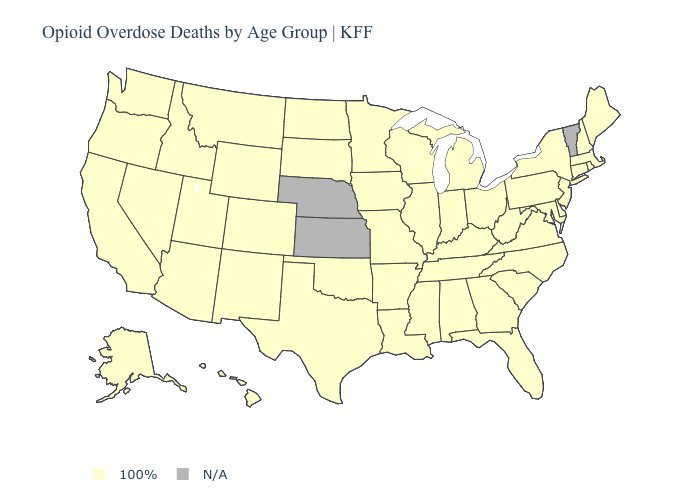Name the states that have a value in the range 100%?
Answer briefly. Alabama, Alaska, Arizona, Arkansas, California, Colorado, Connecticut, Delaware, Florida, Georgia, Hawaii, Idaho, Illinois, Indiana, Iowa, Kentucky, Louisiana, Maine, Maryland, Massachusetts, Michigan, Minnesota, Mississippi, Missouri, Montana, Nevada, New Hampshire, New Jersey, New Mexico, New York, North Carolina, North Dakota, Ohio, Oklahoma, Oregon, Pennsylvania, Rhode Island, South Carolina, South Dakota, Tennessee, Texas, Utah, Virginia, Washington, West Virginia, Wisconsin, Wyoming. Name the states that have a value in the range 100%?
Keep it brief. Alabama, Alaska, Arizona, Arkansas, California, Colorado, Connecticut, Delaware, Florida, Georgia, Hawaii, Idaho, Illinois, Indiana, Iowa, Kentucky, Louisiana, Maine, Maryland, Massachusetts, Michigan, Minnesota, Mississippi, Missouri, Montana, Nevada, New Hampshire, New Jersey, New Mexico, New York, North Carolina, North Dakota, Ohio, Oklahoma, Oregon, Pennsylvania, Rhode Island, South Carolina, South Dakota, Tennessee, Texas, Utah, Virginia, Washington, West Virginia, Wisconsin, Wyoming. Name the states that have a value in the range 100%?
Short answer required. Alabama, Alaska, Arizona, Arkansas, California, Colorado, Connecticut, Delaware, Florida, Georgia, Hawaii, Idaho, Illinois, Indiana, Iowa, Kentucky, Louisiana, Maine, Maryland, Massachusetts, Michigan, Minnesota, Mississippi, Missouri, Montana, Nevada, New Hampshire, New Jersey, New Mexico, New York, North Carolina, North Dakota, Ohio, Oklahoma, Oregon, Pennsylvania, Rhode Island, South Carolina, South Dakota, Tennessee, Texas, Utah, Virginia, Washington, West Virginia, Wisconsin, Wyoming. What is the value of New Hampshire?
Short answer required. 100%. Which states have the highest value in the USA?
Keep it brief. Alabama, Alaska, Arizona, Arkansas, California, Colorado, Connecticut, Delaware, Florida, Georgia, Hawaii, Idaho, Illinois, Indiana, Iowa, Kentucky, Louisiana, Maine, Maryland, Massachusetts, Michigan, Minnesota, Mississippi, Missouri, Montana, Nevada, New Hampshire, New Jersey, New Mexico, New York, North Carolina, North Dakota, Ohio, Oklahoma, Oregon, Pennsylvania, Rhode Island, South Carolina, South Dakota, Tennessee, Texas, Utah, Virginia, Washington, West Virginia, Wisconsin, Wyoming. Which states have the highest value in the USA?
Write a very short answer. Alabama, Alaska, Arizona, Arkansas, California, Colorado, Connecticut, Delaware, Florida, Georgia, Hawaii, Idaho, Illinois, Indiana, Iowa, Kentucky, Louisiana, Maine, Maryland, Massachusetts, Michigan, Minnesota, Mississippi, Missouri, Montana, Nevada, New Hampshire, New Jersey, New Mexico, New York, North Carolina, North Dakota, Ohio, Oklahoma, Oregon, Pennsylvania, Rhode Island, South Carolina, South Dakota, Tennessee, Texas, Utah, Virginia, Washington, West Virginia, Wisconsin, Wyoming. Which states have the lowest value in the USA?
Concise answer only. Alabama, Alaska, Arizona, Arkansas, California, Colorado, Connecticut, Delaware, Florida, Georgia, Hawaii, Idaho, Illinois, Indiana, Iowa, Kentucky, Louisiana, Maine, Maryland, Massachusetts, Michigan, Minnesota, Mississippi, Missouri, Montana, Nevada, New Hampshire, New Jersey, New Mexico, New York, North Carolina, North Dakota, Ohio, Oklahoma, Oregon, Pennsylvania, Rhode Island, South Carolina, South Dakota, Tennessee, Texas, Utah, Virginia, Washington, West Virginia, Wisconsin, Wyoming. What is the value of Montana?
Be succinct. 100%. Name the states that have a value in the range N/A?
Give a very brief answer. Kansas, Nebraska, Vermont. What is the value of Kansas?
Answer briefly. N/A. 